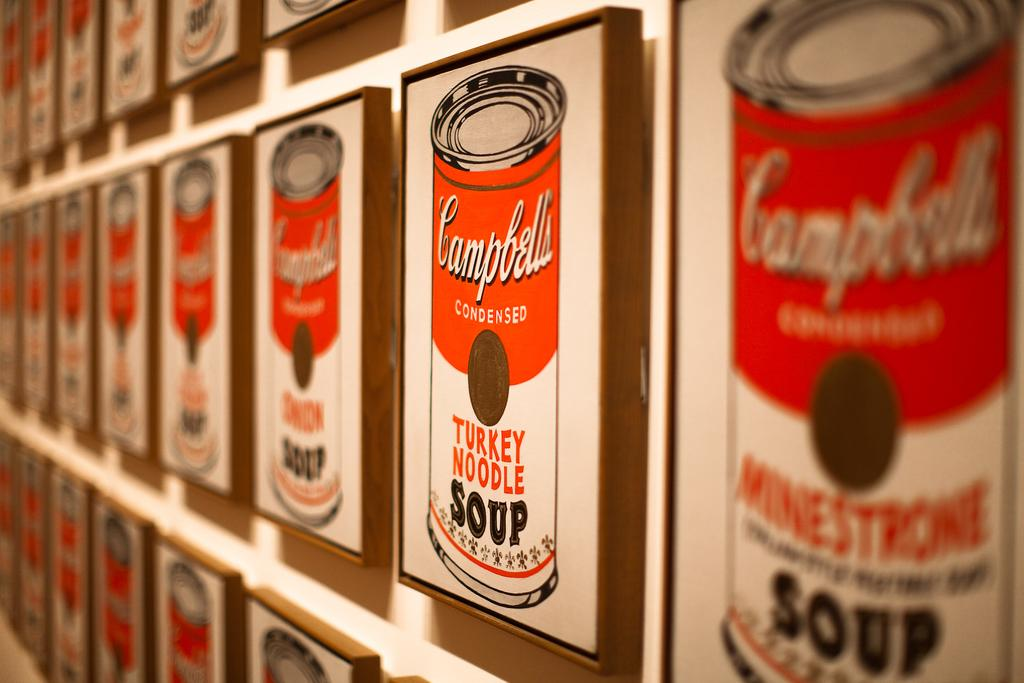What is attached to the wall in the image? There are poster boards on the wall in the image. What type of insect can be seen crawling on the poster boards in the image? There are no insects present on the poster boards in the image. What hobbies are the people in the image pursuing based on the poster boards? The image does not provide information about the people or their hobbies, as it only shows the poster boards on the wall. 